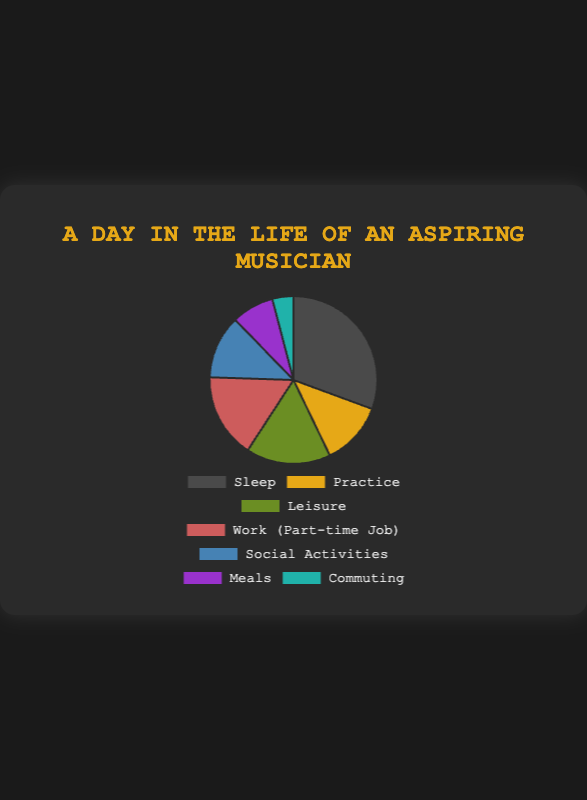What activity takes up the most hours in a day? Identify the segment with the largest value, which is Sleep with 7.5 hours
Answer: Sleep What is the total time spent on Practice and Social Activities combined? Add the hours spent on Practice (3) and Social Activities (3): 3 + 3 = 6 hours
Answer: 6 hours Which activities have the same amount of time allocated to them? Both Practice and Social Activities have 3 hours allocated each
Answer: Practice and Social Activities What is the difference in hours spent between Sleep and Work? Subtract the hours spent on Work (4) from Sleep (7.5): 7.5 - 4 = 3.5 hours
Answer: 3.5 hours What proportion of the day is spent on Leisure activities? Calculate the proportion by dividing Leisure hours by total hours and multiplying by 100: (4 / 24) * 100 ≈ 16.67%
Answer: Approximately 16.67% Which activity has the smallest allocation, and how many hours does it represent? Identify the segment with the smallest value, which is Commuting with 1 hour
Answer: Commuting (1 hour) If 1 additional hour is spent on Meals, what will be the new total time per day? Add the current hours spent on Meals (2) with the additional hour (1): 2 + 1 = 3 hours
Answer: 3 hours How does the time spent on Sleep compare to the time spent on Work and Practice combined? Add the hours for Work (4) and Practice (3) to compare with Sleep: 4 + 3 = 7; Sleep with 7.5 is greater than 7
Answer: Sleep > Work + Practice What is the total number of hours spent on Meals and Commuting combined? Add the hours spent on Meals (2) and Commuting (1): 2 + 1 = 3 hours
Answer: 3 hours What color represents the time spent on Social Activities in the pie chart? Identify the color associated with Social Activities, which is a shade of blue
Answer: Blue 